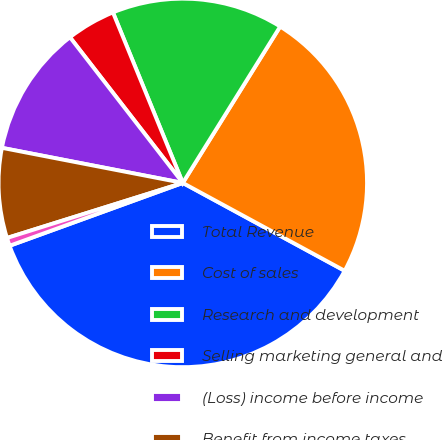Convert chart to OTSL. <chart><loc_0><loc_0><loc_500><loc_500><pie_chart><fcel>Total Revenue<fcel>Cost of sales<fcel>Research and development<fcel>Selling marketing general and<fcel>(Loss) income before income<fcel>Benefit from income taxes<fcel>Net (loss) income from<nl><fcel>36.54%<fcel>24.05%<fcel>15.05%<fcel>4.3%<fcel>11.46%<fcel>7.88%<fcel>0.71%<nl></chart> 